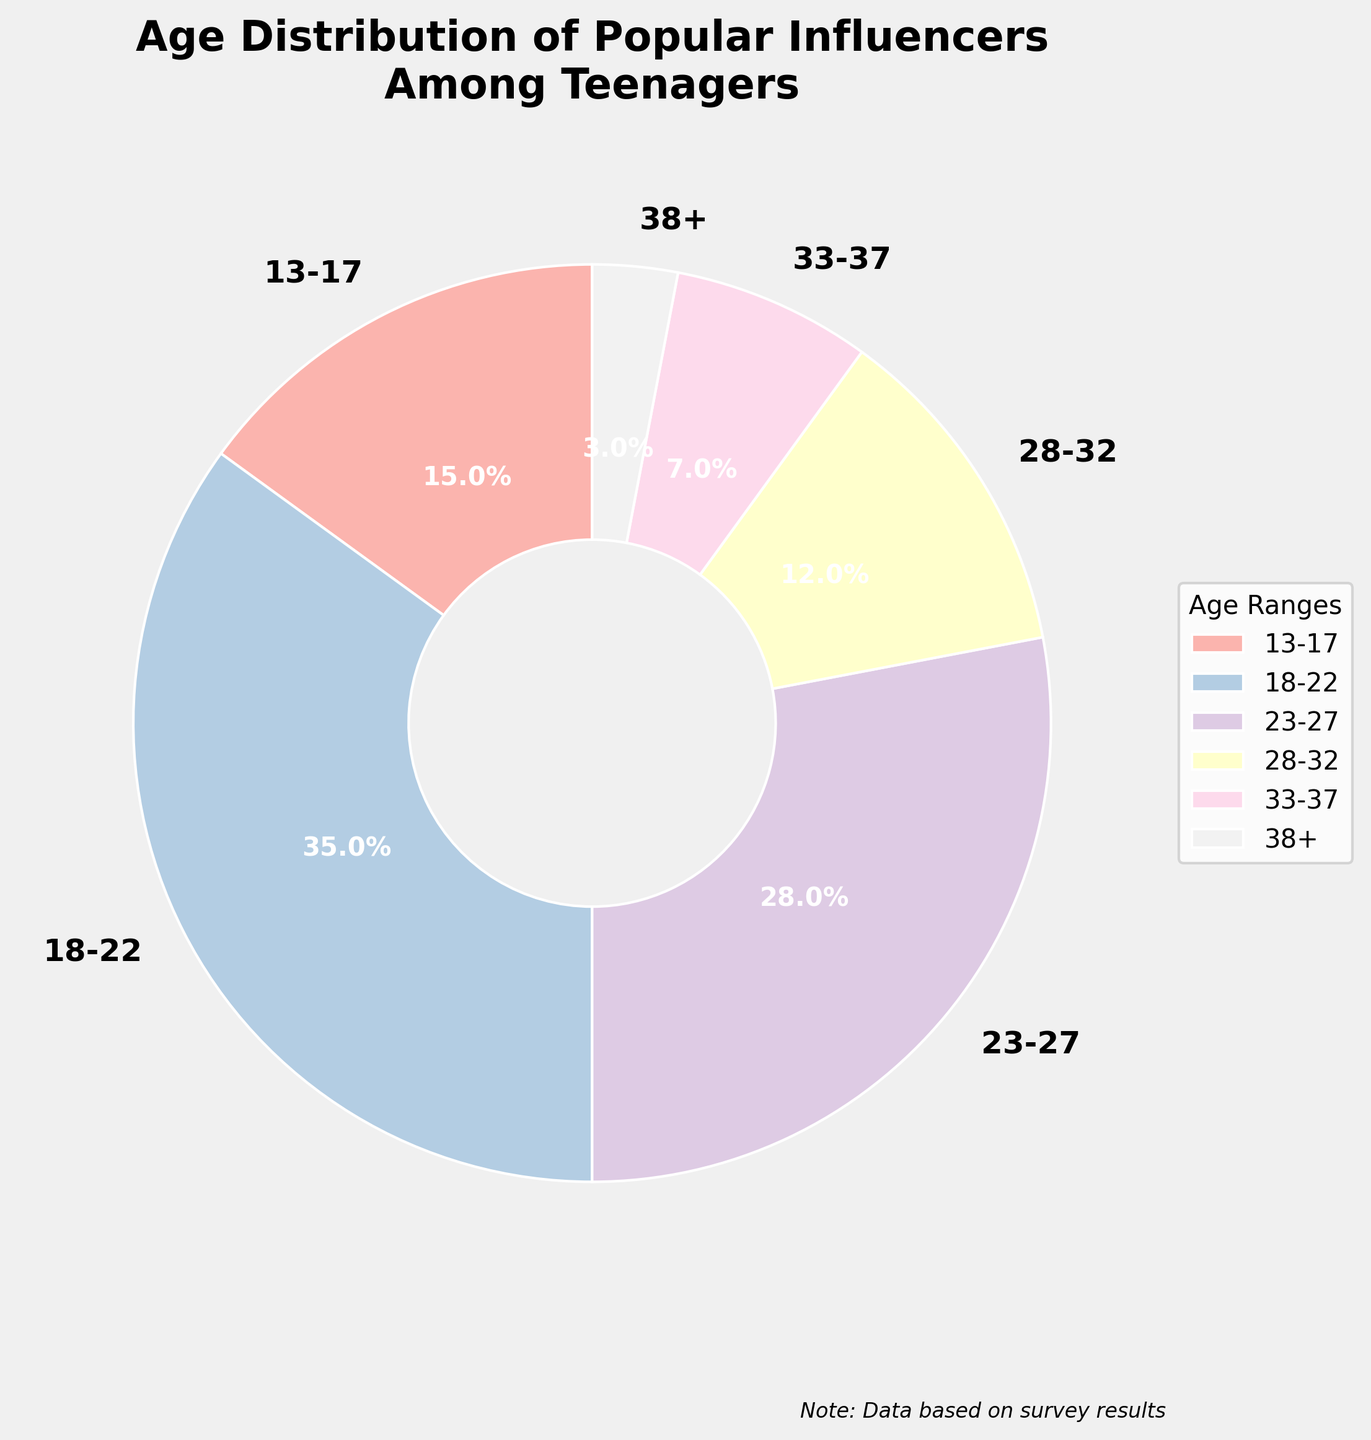What age range has the highest percentage of popular influencers among teenagers? The segment with the largest portion of the pie chart is 18-22.
Answer: 18-22 Which age group comes immediately after the 18-22 age range in popularity? The next largest segment after 18-22, occupying the second largest area in the pie chart, is 23-27.
Answer: 23-27 What is the total percentage of popular influencers in the age range 28-32 and 33-37 combined? Adding the percentages of the 28-32 (12%) and 33-37 (7%) age ranges gives 12% + 7% = 19%.
Answer: 19% Are there more influencers in the 13-17 age range or in the 28-32 age range? Comparing the two pie slices, 15% for 13-17 and 12% for 28-32, shows that 13-17 has a higher percentage.
Answer: 13-17 What is the visual color assigned to the age range 33-37, and what does it signify? The segment for 33-37 uses a pastel color from the pie chart, signifying 7% of the total influencers. Since the exact color names are not specified, it's a pastel shade.
Answer: Pastel shade Which age range has the smallest representation among popular influencers? The smallest slice of the pie chart corresponds to the 38+ age range, with 3%.
Answer: 38+ How much larger is the percentage of popular influencers in the 18-22 age range compared to the 33-37 age range? Subtracting the percentage of 33-37 (7%) from 18-22 (35%) gives 35% - 7% = 28%.
Answer: 28% What is the percentage of influencers under 23 years old? Summing the percentages of the 13-17 (15%) and 18-22 (35%) age ranges gives 15% + 35% = 50%.
Answer: 50% Which age range contributes more to popular influencers, 28-32 or the combined group of 33-37 and 38+? The combined percentage for 33-37 (7%) and 38+ (3%) is 7% + 3% = 10%, whereas 28-32 is 12%. Hence, 28-32 is larger.
Answer: 28-32 